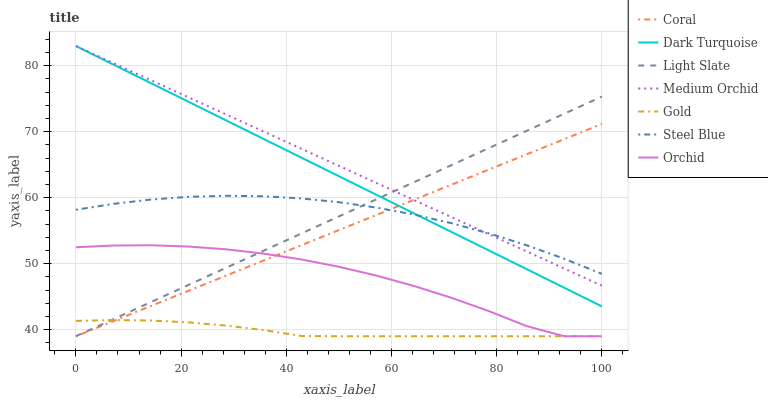Does Gold have the minimum area under the curve?
Answer yes or no. Yes. Does Medium Orchid have the maximum area under the curve?
Answer yes or no. Yes. Does Light Slate have the minimum area under the curve?
Answer yes or no. No. Does Light Slate have the maximum area under the curve?
Answer yes or no. No. Is Medium Orchid the smoothest?
Answer yes or no. Yes. Is Orchid the roughest?
Answer yes or no. Yes. Is Light Slate the smoothest?
Answer yes or no. No. Is Light Slate the roughest?
Answer yes or no. No. Does Dark Turquoise have the lowest value?
Answer yes or no. No. Does Medium Orchid have the highest value?
Answer yes or no. Yes. Does Light Slate have the highest value?
Answer yes or no. No. Is Gold less than Medium Orchid?
Answer yes or no. Yes. Is Dark Turquoise greater than Orchid?
Answer yes or no. Yes. Does Orchid intersect Light Slate?
Answer yes or no. Yes. Is Orchid less than Light Slate?
Answer yes or no. No. Is Orchid greater than Light Slate?
Answer yes or no. No. Does Gold intersect Medium Orchid?
Answer yes or no. No. 